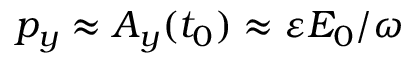Convert formula to latex. <formula><loc_0><loc_0><loc_500><loc_500>p _ { y } \approx A _ { y } ( t _ { 0 } ) \approx \varepsilon E _ { 0 } / \omega</formula> 